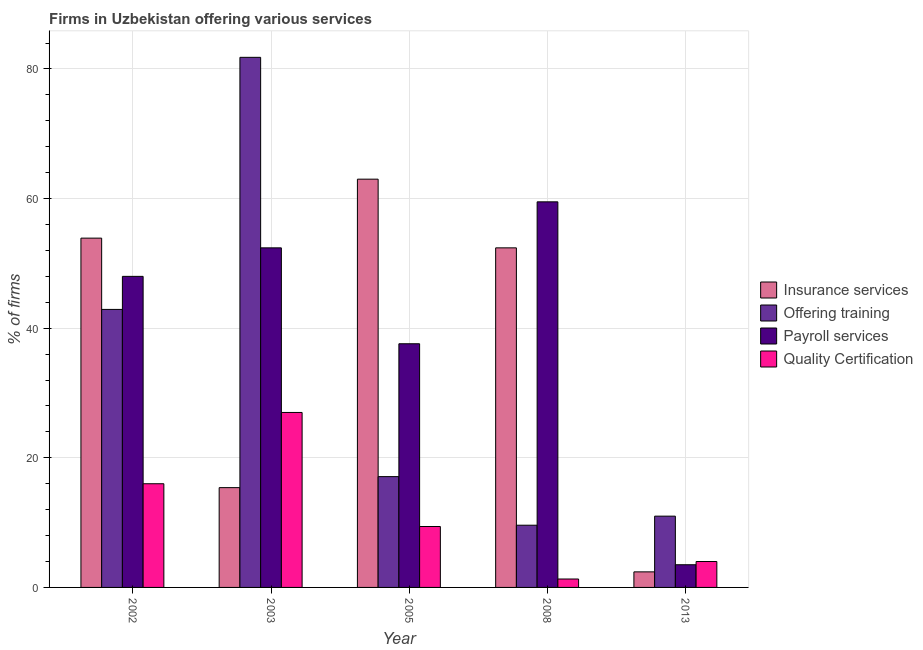How many different coloured bars are there?
Your answer should be very brief. 4. How many groups of bars are there?
Make the answer very short. 5. Are the number of bars on each tick of the X-axis equal?
Provide a short and direct response. Yes. How many bars are there on the 4th tick from the right?
Your answer should be compact. 4. What is the label of the 3rd group of bars from the left?
Your answer should be very brief. 2005. What is the percentage of firms offering training in 2003?
Your response must be concise. 81.8. Across all years, what is the maximum percentage of firms offering training?
Your response must be concise. 81.8. In which year was the percentage of firms offering payroll services maximum?
Give a very brief answer. 2008. What is the total percentage of firms offering payroll services in the graph?
Your answer should be very brief. 201. What is the difference between the percentage of firms offering payroll services in 2003 and the percentage of firms offering quality certification in 2002?
Provide a short and direct response. 4.4. What is the average percentage of firms offering payroll services per year?
Keep it short and to the point. 40.2. In how many years, is the percentage of firms offering quality certification greater than 20 %?
Your answer should be very brief. 1. What is the ratio of the percentage of firms offering payroll services in 2002 to that in 2013?
Keep it short and to the point. 13.71. Is the difference between the percentage of firms offering quality certification in 2003 and 2008 greater than the difference between the percentage of firms offering training in 2003 and 2008?
Provide a succinct answer. No. What is the difference between the highest and the lowest percentage of firms offering insurance services?
Your answer should be very brief. 60.6. In how many years, is the percentage of firms offering training greater than the average percentage of firms offering training taken over all years?
Offer a terse response. 2. Is the sum of the percentage of firms offering training in 2003 and 2008 greater than the maximum percentage of firms offering payroll services across all years?
Keep it short and to the point. Yes. Is it the case that in every year, the sum of the percentage of firms offering training and percentage of firms offering insurance services is greater than the sum of percentage of firms offering quality certification and percentage of firms offering payroll services?
Ensure brevity in your answer.  No. What does the 1st bar from the left in 2013 represents?
Provide a short and direct response. Insurance services. What does the 1st bar from the right in 2003 represents?
Give a very brief answer. Quality Certification. What is the difference between two consecutive major ticks on the Y-axis?
Make the answer very short. 20. Does the graph contain any zero values?
Your answer should be compact. No. Does the graph contain grids?
Ensure brevity in your answer.  Yes. Where does the legend appear in the graph?
Keep it short and to the point. Center right. How many legend labels are there?
Provide a succinct answer. 4. How are the legend labels stacked?
Your answer should be very brief. Vertical. What is the title of the graph?
Keep it short and to the point. Firms in Uzbekistan offering various services . What is the label or title of the Y-axis?
Offer a terse response. % of firms. What is the % of firms of Insurance services in 2002?
Make the answer very short. 53.9. What is the % of firms in Offering training in 2002?
Your response must be concise. 42.9. What is the % of firms of Offering training in 2003?
Offer a very short reply. 81.8. What is the % of firms of Payroll services in 2003?
Your response must be concise. 52.4. What is the % of firms in Insurance services in 2005?
Your answer should be compact. 63. What is the % of firms in Offering training in 2005?
Give a very brief answer. 17.1. What is the % of firms in Payroll services in 2005?
Provide a short and direct response. 37.6. What is the % of firms of Insurance services in 2008?
Offer a very short reply. 52.4. What is the % of firms in Payroll services in 2008?
Give a very brief answer. 59.5. What is the % of firms in Insurance services in 2013?
Your response must be concise. 2.4. Across all years, what is the maximum % of firms of Offering training?
Provide a short and direct response. 81.8. Across all years, what is the maximum % of firms in Payroll services?
Make the answer very short. 59.5. Across all years, what is the maximum % of firms of Quality Certification?
Your answer should be compact. 27. Across all years, what is the minimum % of firms in Payroll services?
Your answer should be compact. 3.5. Across all years, what is the minimum % of firms of Quality Certification?
Offer a very short reply. 1.3. What is the total % of firms in Insurance services in the graph?
Provide a succinct answer. 187.1. What is the total % of firms in Offering training in the graph?
Give a very brief answer. 162.4. What is the total % of firms in Payroll services in the graph?
Provide a short and direct response. 201. What is the total % of firms of Quality Certification in the graph?
Offer a terse response. 57.7. What is the difference between the % of firms in Insurance services in 2002 and that in 2003?
Give a very brief answer. 38.5. What is the difference between the % of firms in Offering training in 2002 and that in 2003?
Your answer should be compact. -38.9. What is the difference between the % of firms in Payroll services in 2002 and that in 2003?
Provide a short and direct response. -4.4. What is the difference between the % of firms of Quality Certification in 2002 and that in 2003?
Offer a very short reply. -11. What is the difference between the % of firms in Offering training in 2002 and that in 2005?
Your response must be concise. 25.8. What is the difference between the % of firms of Quality Certification in 2002 and that in 2005?
Your answer should be very brief. 6.6. What is the difference between the % of firms of Offering training in 2002 and that in 2008?
Make the answer very short. 33.3. What is the difference between the % of firms in Payroll services in 2002 and that in 2008?
Provide a succinct answer. -11.5. What is the difference between the % of firms in Quality Certification in 2002 and that in 2008?
Your answer should be compact. 14.7. What is the difference between the % of firms of Insurance services in 2002 and that in 2013?
Provide a short and direct response. 51.5. What is the difference between the % of firms of Offering training in 2002 and that in 2013?
Your answer should be compact. 31.9. What is the difference between the % of firms in Payroll services in 2002 and that in 2013?
Keep it short and to the point. 44.5. What is the difference between the % of firms in Quality Certification in 2002 and that in 2013?
Your answer should be very brief. 12. What is the difference between the % of firms of Insurance services in 2003 and that in 2005?
Keep it short and to the point. -47.6. What is the difference between the % of firms in Offering training in 2003 and that in 2005?
Your response must be concise. 64.7. What is the difference between the % of firms of Insurance services in 2003 and that in 2008?
Your response must be concise. -37. What is the difference between the % of firms in Offering training in 2003 and that in 2008?
Offer a very short reply. 72.2. What is the difference between the % of firms of Quality Certification in 2003 and that in 2008?
Your response must be concise. 25.7. What is the difference between the % of firms in Offering training in 2003 and that in 2013?
Your answer should be very brief. 70.8. What is the difference between the % of firms of Payroll services in 2003 and that in 2013?
Make the answer very short. 48.9. What is the difference between the % of firms of Offering training in 2005 and that in 2008?
Offer a terse response. 7.5. What is the difference between the % of firms of Payroll services in 2005 and that in 2008?
Your answer should be compact. -21.9. What is the difference between the % of firms in Insurance services in 2005 and that in 2013?
Offer a very short reply. 60.6. What is the difference between the % of firms in Offering training in 2005 and that in 2013?
Give a very brief answer. 6.1. What is the difference between the % of firms in Payroll services in 2005 and that in 2013?
Offer a terse response. 34.1. What is the difference between the % of firms in Quality Certification in 2005 and that in 2013?
Give a very brief answer. 5.4. What is the difference between the % of firms in Payroll services in 2008 and that in 2013?
Make the answer very short. 56. What is the difference between the % of firms in Quality Certification in 2008 and that in 2013?
Your answer should be compact. -2.7. What is the difference between the % of firms of Insurance services in 2002 and the % of firms of Offering training in 2003?
Make the answer very short. -27.9. What is the difference between the % of firms of Insurance services in 2002 and the % of firms of Quality Certification in 2003?
Make the answer very short. 26.9. What is the difference between the % of firms in Offering training in 2002 and the % of firms in Quality Certification in 2003?
Provide a short and direct response. 15.9. What is the difference between the % of firms in Payroll services in 2002 and the % of firms in Quality Certification in 2003?
Give a very brief answer. 21. What is the difference between the % of firms of Insurance services in 2002 and the % of firms of Offering training in 2005?
Your answer should be compact. 36.8. What is the difference between the % of firms in Insurance services in 2002 and the % of firms in Payroll services in 2005?
Provide a succinct answer. 16.3. What is the difference between the % of firms of Insurance services in 2002 and the % of firms of Quality Certification in 2005?
Your answer should be compact. 44.5. What is the difference between the % of firms in Offering training in 2002 and the % of firms in Payroll services in 2005?
Offer a terse response. 5.3. What is the difference between the % of firms of Offering training in 2002 and the % of firms of Quality Certification in 2005?
Your answer should be very brief. 33.5. What is the difference between the % of firms in Payroll services in 2002 and the % of firms in Quality Certification in 2005?
Make the answer very short. 38.6. What is the difference between the % of firms in Insurance services in 2002 and the % of firms in Offering training in 2008?
Offer a terse response. 44.3. What is the difference between the % of firms of Insurance services in 2002 and the % of firms of Quality Certification in 2008?
Your answer should be very brief. 52.6. What is the difference between the % of firms of Offering training in 2002 and the % of firms of Payroll services in 2008?
Your answer should be compact. -16.6. What is the difference between the % of firms of Offering training in 2002 and the % of firms of Quality Certification in 2008?
Your response must be concise. 41.6. What is the difference between the % of firms of Payroll services in 2002 and the % of firms of Quality Certification in 2008?
Make the answer very short. 46.7. What is the difference between the % of firms in Insurance services in 2002 and the % of firms in Offering training in 2013?
Your answer should be very brief. 42.9. What is the difference between the % of firms of Insurance services in 2002 and the % of firms of Payroll services in 2013?
Offer a terse response. 50.4. What is the difference between the % of firms of Insurance services in 2002 and the % of firms of Quality Certification in 2013?
Give a very brief answer. 49.9. What is the difference between the % of firms of Offering training in 2002 and the % of firms of Payroll services in 2013?
Your response must be concise. 39.4. What is the difference between the % of firms in Offering training in 2002 and the % of firms in Quality Certification in 2013?
Provide a succinct answer. 38.9. What is the difference between the % of firms of Payroll services in 2002 and the % of firms of Quality Certification in 2013?
Ensure brevity in your answer.  44. What is the difference between the % of firms in Insurance services in 2003 and the % of firms in Payroll services in 2005?
Offer a very short reply. -22.2. What is the difference between the % of firms of Insurance services in 2003 and the % of firms of Quality Certification in 2005?
Ensure brevity in your answer.  6. What is the difference between the % of firms of Offering training in 2003 and the % of firms of Payroll services in 2005?
Your answer should be very brief. 44.2. What is the difference between the % of firms in Offering training in 2003 and the % of firms in Quality Certification in 2005?
Provide a succinct answer. 72.4. What is the difference between the % of firms in Payroll services in 2003 and the % of firms in Quality Certification in 2005?
Provide a short and direct response. 43. What is the difference between the % of firms in Insurance services in 2003 and the % of firms in Payroll services in 2008?
Your response must be concise. -44.1. What is the difference between the % of firms of Insurance services in 2003 and the % of firms of Quality Certification in 2008?
Offer a very short reply. 14.1. What is the difference between the % of firms in Offering training in 2003 and the % of firms in Payroll services in 2008?
Offer a terse response. 22.3. What is the difference between the % of firms of Offering training in 2003 and the % of firms of Quality Certification in 2008?
Keep it short and to the point. 80.5. What is the difference between the % of firms of Payroll services in 2003 and the % of firms of Quality Certification in 2008?
Provide a short and direct response. 51.1. What is the difference between the % of firms in Insurance services in 2003 and the % of firms in Quality Certification in 2013?
Offer a terse response. 11.4. What is the difference between the % of firms of Offering training in 2003 and the % of firms of Payroll services in 2013?
Provide a succinct answer. 78.3. What is the difference between the % of firms in Offering training in 2003 and the % of firms in Quality Certification in 2013?
Provide a succinct answer. 77.8. What is the difference between the % of firms in Payroll services in 2003 and the % of firms in Quality Certification in 2013?
Give a very brief answer. 48.4. What is the difference between the % of firms of Insurance services in 2005 and the % of firms of Offering training in 2008?
Make the answer very short. 53.4. What is the difference between the % of firms in Insurance services in 2005 and the % of firms in Payroll services in 2008?
Provide a succinct answer. 3.5. What is the difference between the % of firms in Insurance services in 2005 and the % of firms in Quality Certification in 2008?
Your answer should be very brief. 61.7. What is the difference between the % of firms in Offering training in 2005 and the % of firms in Payroll services in 2008?
Your answer should be compact. -42.4. What is the difference between the % of firms in Offering training in 2005 and the % of firms in Quality Certification in 2008?
Keep it short and to the point. 15.8. What is the difference between the % of firms of Payroll services in 2005 and the % of firms of Quality Certification in 2008?
Offer a very short reply. 36.3. What is the difference between the % of firms of Insurance services in 2005 and the % of firms of Offering training in 2013?
Provide a short and direct response. 52. What is the difference between the % of firms of Insurance services in 2005 and the % of firms of Payroll services in 2013?
Give a very brief answer. 59.5. What is the difference between the % of firms in Offering training in 2005 and the % of firms in Payroll services in 2013?
Keep it short and to the point. 13.6. What is the difference between the % of firms of Payroll services in 2005 and the % of firms of Quality Certification in 2013?
Provide a short and direct response. 33.6. What is the difference between the % of firms in Insurance services in 2008 and the % of firms in Offering training in 2013?
Your answer should be compact. 41.4. What is the difference between the % of firms of Insurance services in 2008 and the % of firms of Payroll services in 2013?
Offer a terse response. 48.9. What is the difference between the % of firms in Insurance services in 2008 and the % of firms in Quality Certification in 2013?
Offer a terse response. 48.4. What is the difference between the % of firms of Offering training in 2008 and the % of firms of Payroll services in 2013?
Provide a short and direct response. 6.1. What is the difference between the % of firms of Payroll services in 2008 and the % of firms of Quality Certification in 2013?
Your answer should be very brief. 55.5. What is the average % of firms in Insurance services per year?
Offer a very short reply. 37.42. What is the average % of firms of Offering training per year?
Provide a succinct answer. 32.48. What is the average % of firms in Payroll services per year?
Offer a very short reply. 40.2. What is the average % of firms in Quality Certification per year?
Your answer should be compact. 11.54. In the year 2002, what is the difference between the % of firms in Insurance services and % of firms in Quality Certification?
Your answer should be very brief. 37.9. In the year 2002, what is the difference between the % of firms of Offering training and % of firms of Payroll services?
Your answer should be very brief. -5.1. In the year 2002, what is the difference between the % of firms of Offering training and % of firms of Quality Certification?
Your answer should be compact. 26.9. In the year 2003, what is the difference between the % of firms of Insurance services and % of firms of Offering training?
Make the answer very short. -66.4. In the year 2003, what is the difference between the % of firms in Insurance services and % of firms in Payroll services?
Make the answer very short. -37. In the year 2003, what is the difference between the % of firms in Offering training and % of firms in Payroll services?
Make the answer very short. 29.4. In the year 2003, what is the difference between the % of firms of Offering training and % of firms of Quality Certification?
Give a very brief answer. 54.8. In the year 2003, what is the difference between the % of firms in Payroll services and % of firms in Quality Certification?
Your answer should be very brief. 25.4. In the year 2005, what is the difference between the % of firms of Insurance services and % of firms of Offering training?
Keep it short and to the point. 45.9. In the year 2005, what is the difference between the % of firms of Insurance services and % of firms of Payroll services?
Your answer should be compact. 25.4. In the year 2005, what is the difference between the % of firms of Insurance services and % of firms of Quality Certification?
Provide a succinct answer. 53.6. In the year 2005, what is the difference between the % of firms of Offering training and % of firms of Payroll services?
Ensure brevity in your answer.  -20.5. In the year 2005, what is the difference between the % of firms of Offering training and % of firms of Quality Certification?
Your answer should be very brief. 7.7. In the year 2005, what is the difference between the % of firms of Payroll services and % of firms of Quality Certification?
Your response must be concise. 28.2. In the year 2008, what is the difference between the % of firms in Insurance services and % of firms in Offering training?
Provide a succinct answer. 42.8. In the year 2008, what is the difference between the % of firms of Insurance services and % of firms of Payroll services?
Provide a succinct answer. -7.1. In the year 2008, what is the difference between the % of firms in Insurance services and % of firms in Quality Certification?
Keep it short and to the point. 51.1. In the year 2008, what is the difference between the % of firms in Offering training and % of firms in Payroll services?
Ensure brevity in your answer.  -49.9. In the year 2008, what is the difference between the % of firms in Offering training and % of firms in Quality Certification?
Offer a terse response. 8.3. In the year 2008, what is the difference between the % of firms of Payroll services and % of firms of Quality Certification?
Your response must be concise. 58.2. In the year 2013, what is the difference between the % of firms in Insurance services and % of firms in Offering training?
Ensure brevity in your answer.  -8.6. In the year 2013, what is the difference between the % of firms in Insurance services and % of firms in Quality Certification?
Ensure brevity in your answer.  -1.6. In the year 2013, what is the difference between the % of firms in Payroll services and % of firms in Quality Certification?
Your response must be concise. -0.5. What is the ratio of the % of firms of Insurance services in 2002 to that in 2003?
Give a very brief answer. 3.5. What is the ratio of the % of firms in Offering training in 2002 to that in 2003?
Offer a terse response. 0.52. What is the ratio of the % of firms of Payroll services in 2002 to that in 2003?
Keep it short and to the point. 0.92. What is the ratio of the % of firms of Quality Certification in 2002 to that in 2003?
Offer a very short reply. 0.59. What is the ratio of the % of firms in Insurance services in 2002 to that in 2005?
Offer a very short reply. 0.86. What is the ratio of the % of firms of Offering training in 2002 to that in 2005?
Provide a succinct answer. 2.51. What is the ratio of the % of firms in Payroll services in 2002 to that in 2005?
Offer a very short reply. 1.28. What is the ratio of the % of firms of Quality Certification in 2002 to that in 2005?
Your answer should be compact. 1.7. What is the ratio of the % of firms in Insurance services in 2002 to that in 2008?
Make the answer very short. 1.03. What is the ratio of the % of firms in Offering training in 2002 to that in 2008?
Provide a succinct answer. 4.47. What is the ratio of the % of firms in Payroll services in 2002 to that in 2008?
Keep it short and to the point. 0.81. What is the ratio of the % of firms of Quality Certification in 2002 to that in 2008?
Your answer should be compact. 12.31. What is the ratio of the % of firms of Insurance services in 2002 to that in 2013?
Make the answer very short. 22.46. What is the ratio of the % of firms of Payroll services in 2002 to that in 2013?
Give a very brief answer. 13.71. What is the ratio of the % of firms of Quality Certification in 2002 to that in 2013?
Your answer should be very brief. 4. What is the ratio of the % of firms of Insurance services in 2003 to that in 2005?
Make the answer very short. 0.24. What is the ratio of the % of firms in Offering training in 2003 to that in 2005?
Give a very brief answer. 4.78. What is the ratio of the % of firms of Payroll services in 2003 to that in 2005?
Keep it short and to the point. 1.39. What is the ratio of the % of firms in Quality Certification in 2003 to that in 2005?
Give a very brief answer. 2.87. What is the ratio of the % of firms of Insurance services in 2003 to that in 2008?
Your answer should be very brief. 0.29. What is the ratio of the % of firms of Offering training in 2003 to that in 2008?
Your answer should be very brief. 8.52. What is the ratio of the % of firms of Payroll services in 2003 to that in 2008?
Your answer should be compact. 0.88. What is the ratio of the % of firms of Quality Certification in 2003 to that in 2008?
Give a very brief answer. 20.77. What is the ratio of the % of firms of Insurance services in 2003 to that in 2013?
Ensure brevity in your answer.  6.42. What is the ratio of the % of firms in Offering training in 2003 to that in 2013?
Make the answer very short. 7.44. What is the ratio of the % of firms in Payroll services in 2003 to that in 2013?
Offer a very short reply. 14.97. What is the ratio of the % of firms of Quality Certification in 2003 to that in 2013?
Ensure brevity in your answer.  6.75. What is the ratio of the % of firms of Insurance services in 2005 to that in 2008?
Provide a short and direct response. 1.2. What is the ratio of the % of firms in Offering training in 2005 to that in 2008?
Your answer should be very brief. 1.78. What is the ratio of the % of firms of Payroll services in 2005 to that in 2008?
Provide a succinct answer. 0.63. What is the ratio of the % of firms in Quality Certification in 2005 to that in 2008?
Your answer should be compact. 7.23. What is the ratio of the % of firms in Insurance services in 2005 to that in 2013?
Ensure brevity in your answer.  26.25. What is the ratio of the % of firms of Offering training in 2005 to that in 2013?
Your answer should be very brief. 1.55. What is the ratio of the % of firms in Payroll services in 2005 to that in 2013?
Your response must be concise. 10.74. What is the ratio of the % of firms in Quality Certification in 2005 to that in 2013?
Offer a very short reply. 2.35. What is the ratio of the % of firms of Insurance services in 2008 to that in 2013?
Ensure brevity in your answer.  21.83. What is the ratio of the % of firms of Offering training in 2008 to that in 2013?
Keep it short and to the point. 0.87. What is the ratio of the % of firms of Payroll services in 2008 to that in 2013?
Keep it short and to the point. 17. What is the ratio of the % of firms of Quality Certification in 2008 to that in 2013?
Give a very brief answer. 0.33. What is the difference between the highest and the second highest % of firms in Offering training?
Give a very brief answer. 38.9. What is the difference between the highest and the second highest % of firms of Payroll services?
Provide a succinct answer. 7.1. What is the difference between the highest and the lowest % of firms of Insurance services?
Your answer should be compact. 60.6. What is the difference between the highest and the lowest % of firms in Offering training?
Offer a terse response. 72.2. What is the difference between the highest and the lowest % of firms in Payroll services?
Make the answer very short. 56. What is the difference between the highest and the lowest % of firms in Quality Certification?
Give a very brief answer. 25.7. 